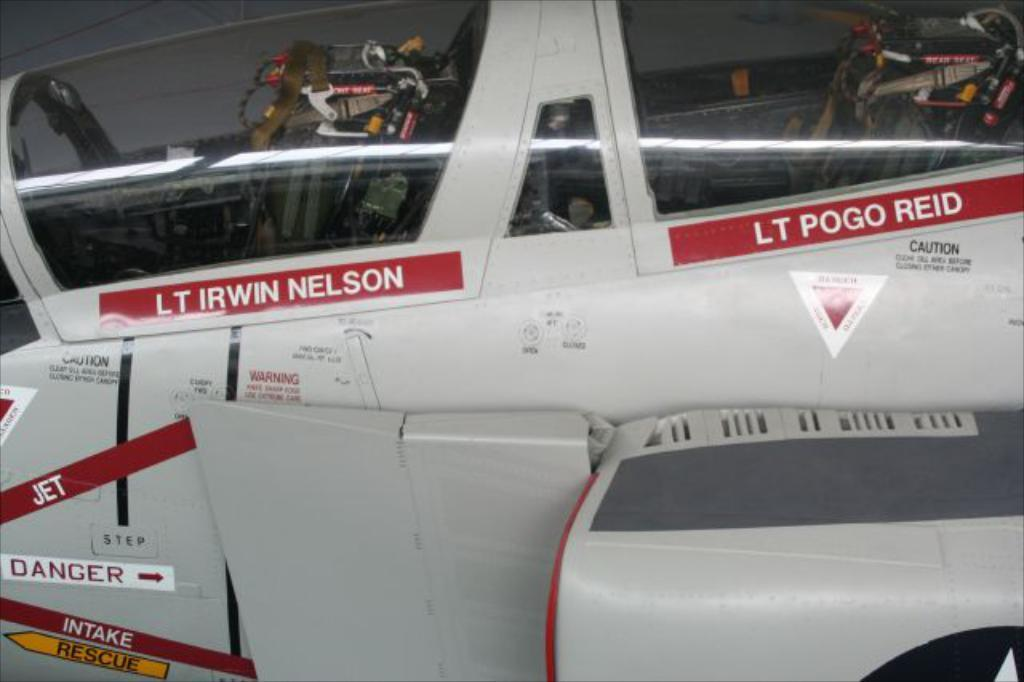<image>
Give a short and clear explanation of the subsequent image. a cockpit of a jet with the name LT Irwin Nelson on the side 